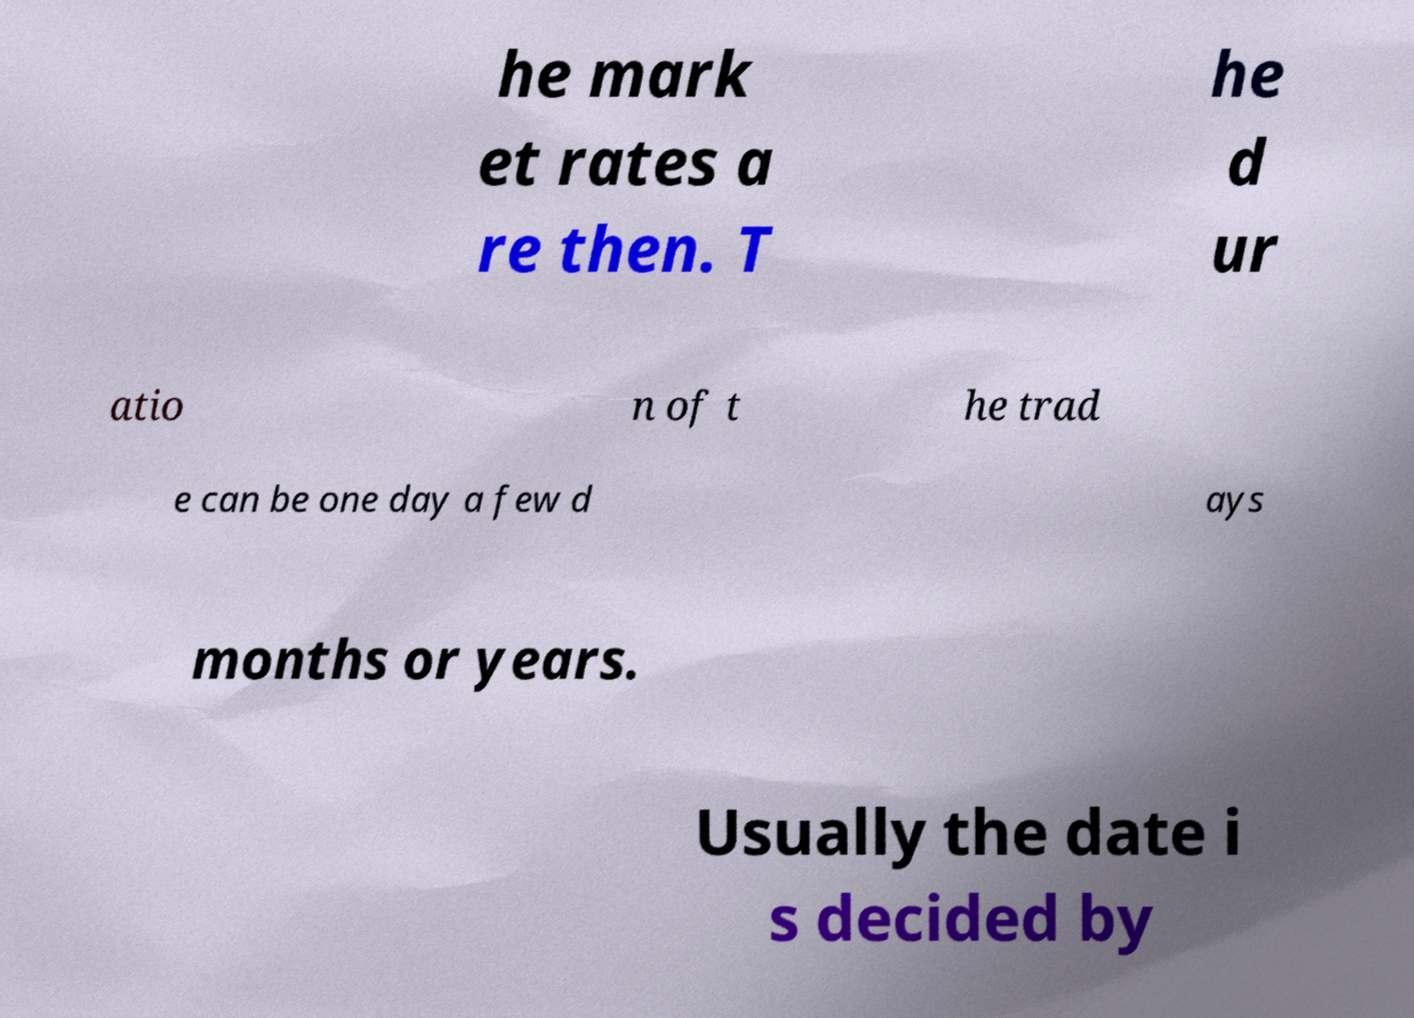Could you extract and type out the text from this image? he mark et rates a re then. T he d ur atio n of t he trad e can be one day a few d ays months or years. Usually the date i s decided by 